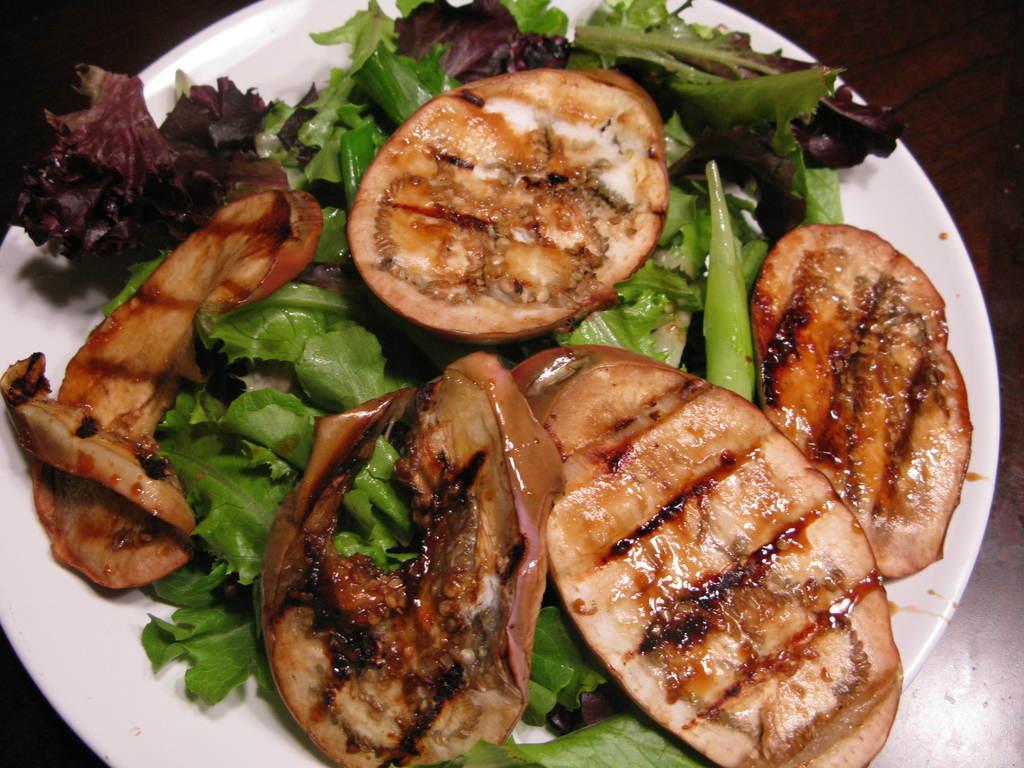In one or two sentences, can you explain what this image depicts? In this image I can see food and some salad on the white plate and background is dark. 